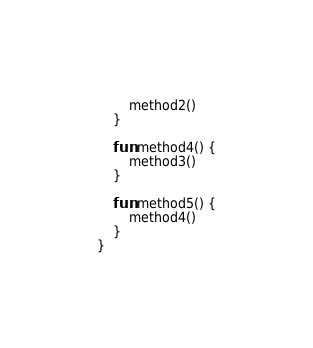Convert code to text. <code><loc_0><loc_0><loc_500><loc_500><_Kotlin_>        method2()
    }

    fun method4() {
        method3()
    }

    fun method5() {
        method4()
    }
}
</code> 